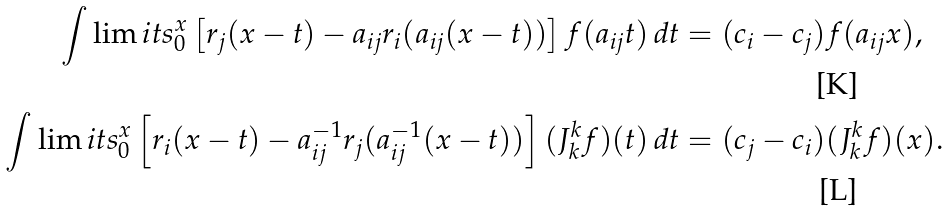Convert formula to latex. <formula><loc_0><loc_0><loc_500><loc_500>\int \lim i t s _ { 0 } ^ { x } \left [ r _ { j } ( x - t ) - a _ { i j } r _ { i } ( a _ { i j } ( x - t ) ) \right ] f ( a _ { i j } t ) \, d t & = ( c _ { i } - c _ { j } ) f ( a _ { i j } x ) , \\ \int \lim i t s _ { 0 } ^ { x } \left [ r _ { i } ( x - t ) - a _ { i j } ^ { - 1 } r _ { j } ( a _ { i j } ^ { - 1 } ( x - t ) ) \right ] ( J _ { k } ^ { k } f ) ( t ) \, d t & = ( c _ { j } - c _ { i } ) ( J _ { k } ^ { k } f ) ( x ) .</formula> 